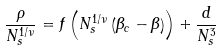Convert formula to latex. <formula><loc_0><loc_0><loc_500><loc_500>\frac { \rho } { N _ { s } ^ { 1 / \nu } } = f \left ( N _ { s } ^ { 1 / \nu } \left ( \beta _ { c } - \beta \right ) \right ) + \frac { d } { N _ { s } ^ { 3 } }</formula> 